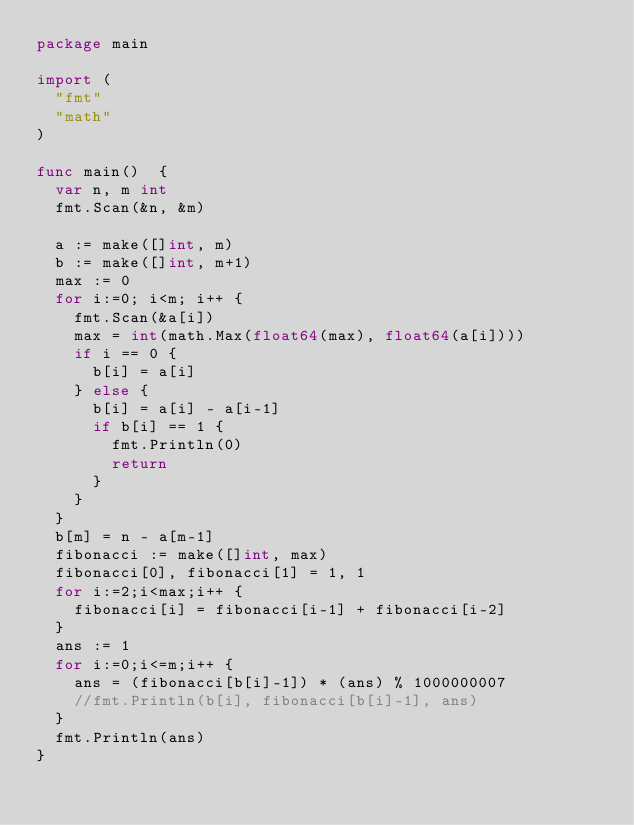<code> <loc_0><loc_0><loc_500><loc_500><_Go_>package main

import (
	"fmt"
	"math"
)

func main()  {
	var n, m int
	fmt.Scan(&n, &m)

	a := make([]int, m)
	b := make([]int, m+1)
	max := 0
	for i:=0; i<m; i++ {
		fmt.Scan(&a[i])
		max = int(math.Max(float64(max), float64(a[i])))
		if i == 0 {
			b[i] = a[i]
		} else {
			b[i] = a[i] - a[i-1]
			if b[i] == 1 {
				fmt.Println(0)
				return
			}
		}
	}
	b[m] = n - a[m-1]
	fibonacci := make([]int, max)
	fibonacci[0], fibonacci[1] = 1, 1
	for i:=2;i<max;i++ {
		fibonacci[i] = fibonacci[i-1] + fibonacci[i-2]
	}
	ans := 1
	for i:=0;i<=m;i++ {
		ans = (fibonacci[b[i]-1]) * (ans) % 1000000007
		//fmt.Println(b[i], fibonacci[b[i]-1], ans)
	}
	fmt.Println(ans)
}</code> 